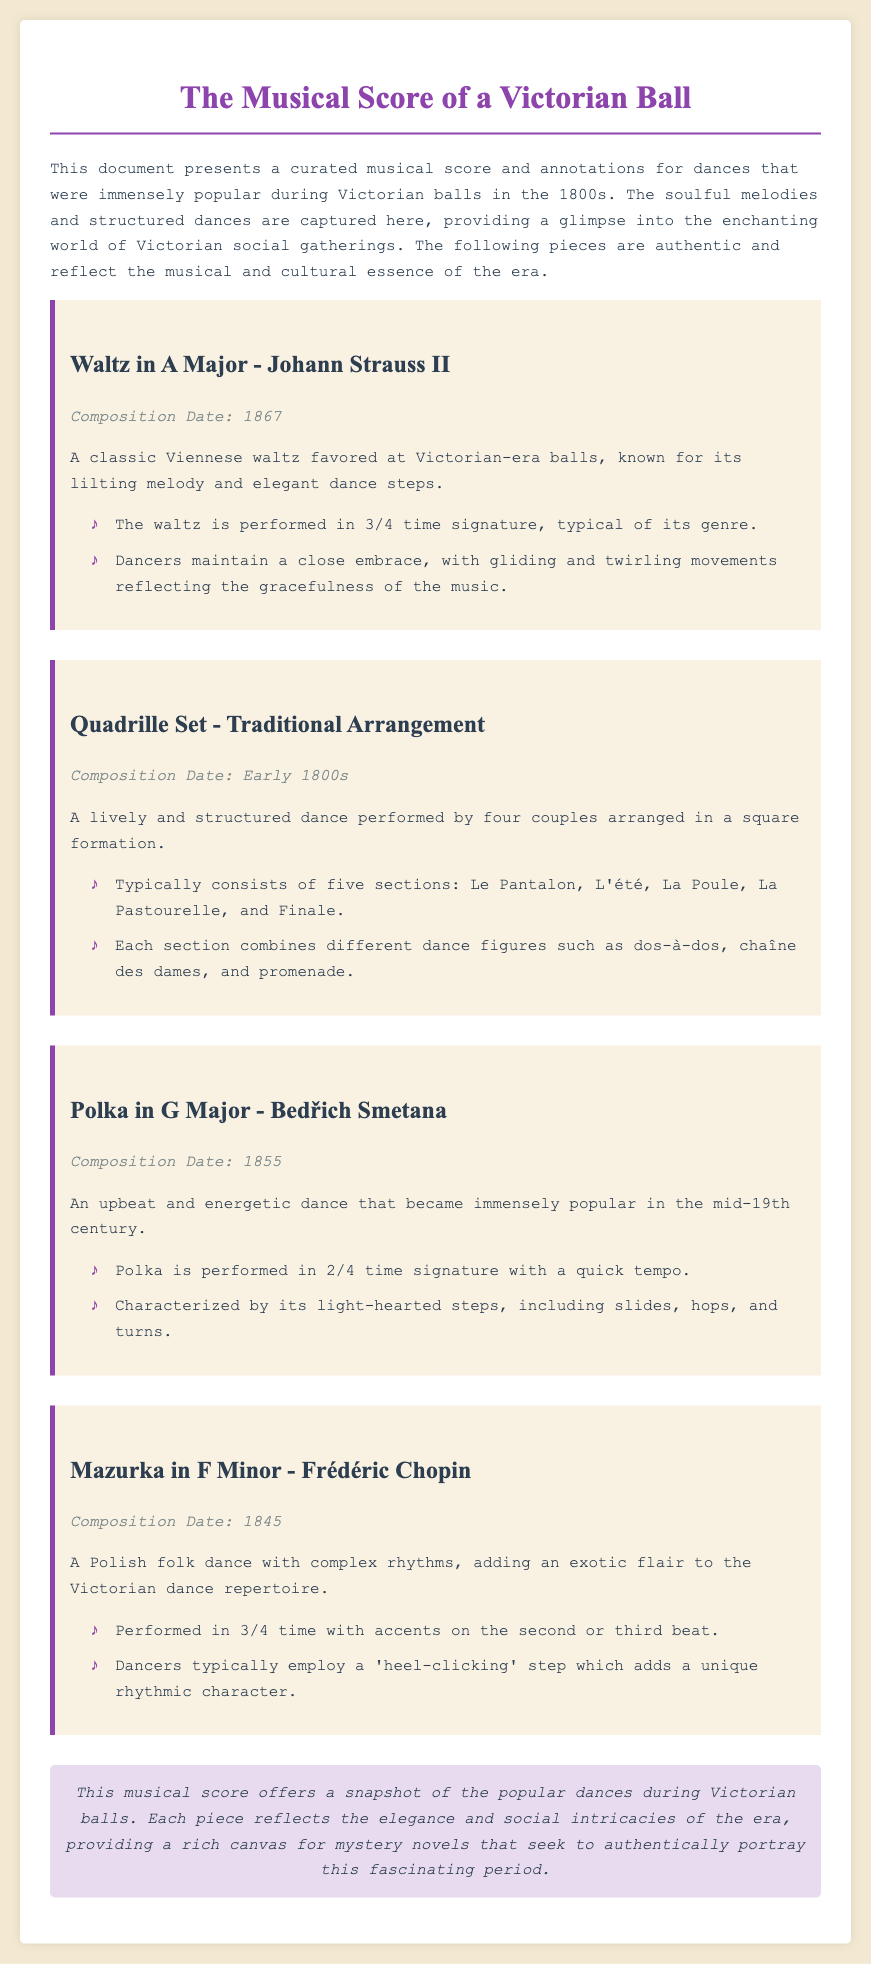What is the title of the document? The title is the main heading of the document that summarizes its content, which is "The Musical Score of a Victorian Ball".
Answer: The Musical Score of a Victorian Ball Who composed the Waltz in A Major? This information can be found in the section describing the piece, which indicates it was composed by Johann Strauss II.
Answer: Johann Strauss II What year was the Polka in G Major composed? The year of composition is indicated in the section that describes the Polka in G Major, which states it was composed in 1855.
Answer: 1855 How many sections are typically in a Quadrille Set? The document states that a Quadrille Set typically consists of five sections.
Answer: Five What time signature is the Mazurka in F Minor performed in? The time signature is mentioned in the annotations for the Mazurka in F Minor, indicating it is performed in 3/4 time.
Answer: 3/4 What dance figure is mentioned in relation to the Quadrille Set? The document specifies several dance figures included in the Quadrille, notably 'dos-à-dos'.
Answer: dos-à-dos What is the genre of the Waltz in A Major? The document categorizes the Waltz in A Major as a classic Viennese waltz.
Answer: Classic Viennese waltz What unique step is used in the Mazurka? The unique step mentioned for the Mazurka adds character to the dance and is referred to as a 'heel-clicking' step.
Answer: Heel-clicking step What is the conclusion of the document? The conclusion summarizes the essence of the document and provides insights about popular dances, stating it is "a snapshot of the popular dances during Victorian balls."
Answer: A snapshot of the popular dances during Victorian balls 